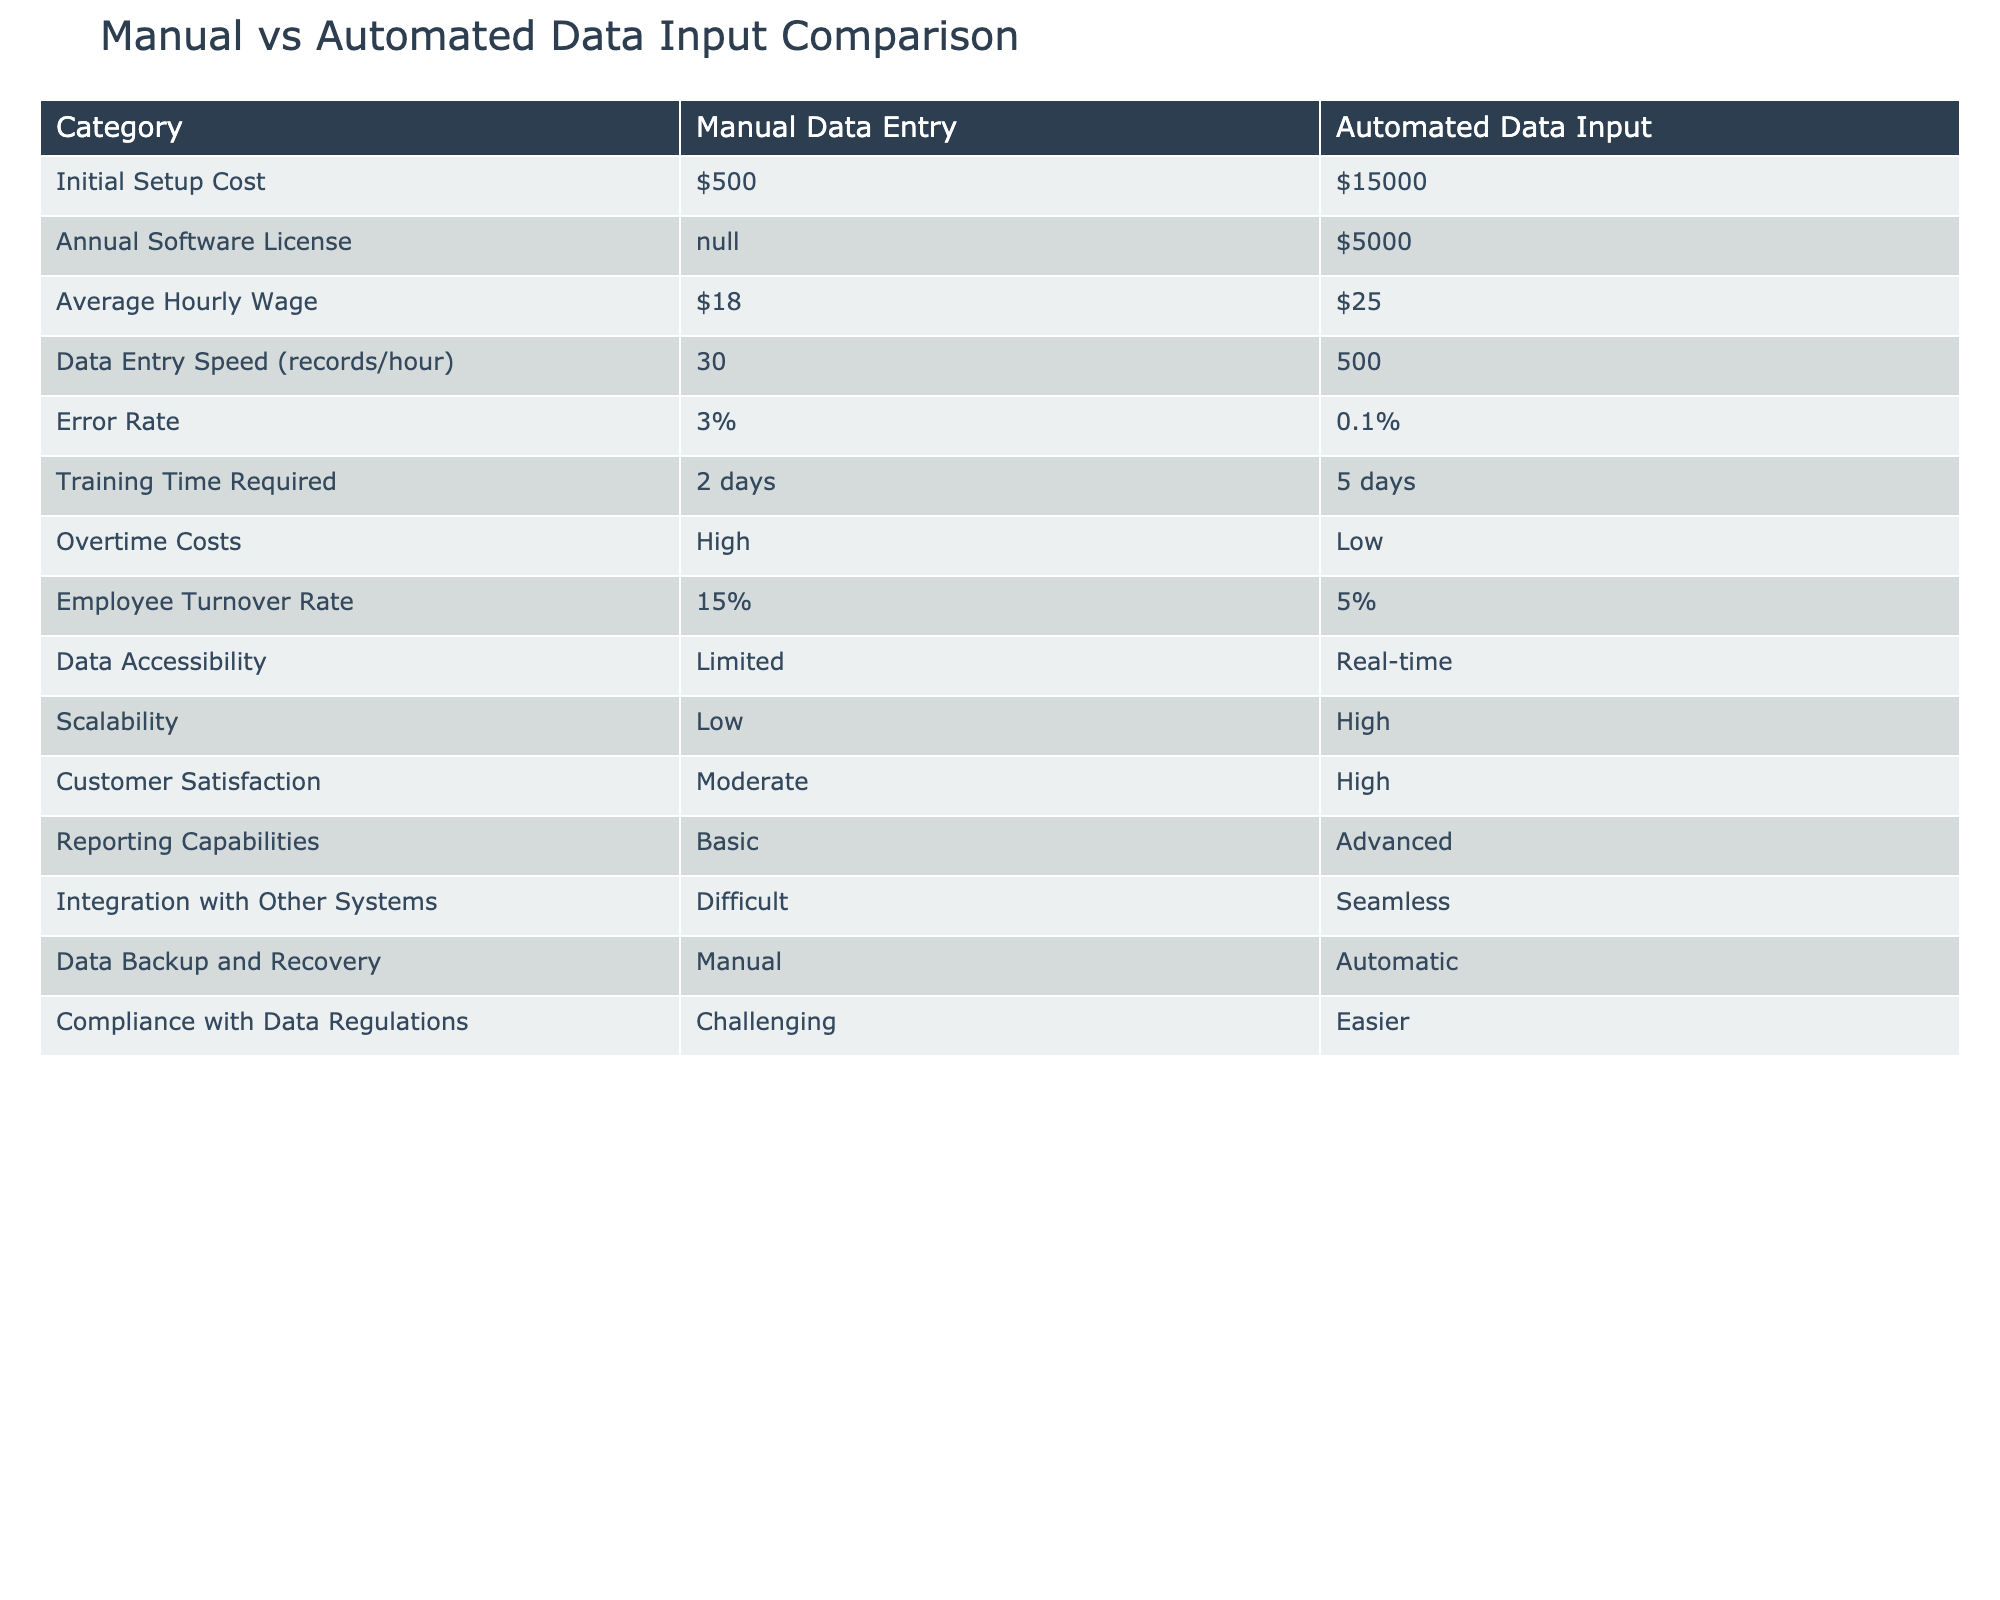What is the initial setup cost for manual data entry? The table lists the initial setup cost for manual data entry as $500. This value can be found directly in the first row under the "Manual Data Entry" column.
Answer: $500 What is the average hourly wage of employees in automated data input? The average hourly wage for employees engaged in automated data input processes is $25, as displayed in the corresponding row of the table under the "Automated Data Input" column.
Answer: $25 Is the error rate lower in automated data input compared to manual data entry? The error rate in automated data input is 0.1%, while the error rate for manual data entry is 3%. Since 0.1% is less than 3%, the statement is true.
Answer: Yes How much higher is the annual software license cost for automated data input compared to manual data entry? The annual software license cost for manual data entry is N/A, and for automated data input, it is $5000. Since one value is N/A, we cannot calculate a difference from manual data entry. Thus we cannot determine a higher cost.
Answer: Not applicable What is the difference in data entry speed between manual data entry and automated data input? According to the table, manual data entry has a speed of 30 records per hour, while automated data input has a speed of 500 records per hour. The difference is 500 - 30 = 470 records per hour, indicating that automated data input is significantly faster.
Answer: 470 records per hour Does the training time required for automated data input exceed that of manual data entry? The training time required for manual data entry is 2 days, while for automated data input, it is 5 days. Since 5 days is greater than 2 days, the statement is true.
Answer: Yes What is the combined effect of employee turnover rates for both data entry methods? The turnover rate for manual data entry is 15%, and for automated data input, it is 5%. Adding these together gives 15% + 5% = 20%. This value is found by straightforward addition of the two percentages.
Answer: 20% Which data entry method has better scalability, and what is the comparative value? The table indicates that manual data entry has low scalability, while automated data input has high scalability. Therefore, automated data input is the method with better scalability.
Answer: Automated data input How does customer satisfaction differ between the two data entry processes? Customer satisfaction is moderate for manual data entry and high for automated data input according to the respective rows in the table. The difference in satisfaction levels indicates that automated data input is preferable in terms of customer satisfaction.
Answer: Higher for automated data input 